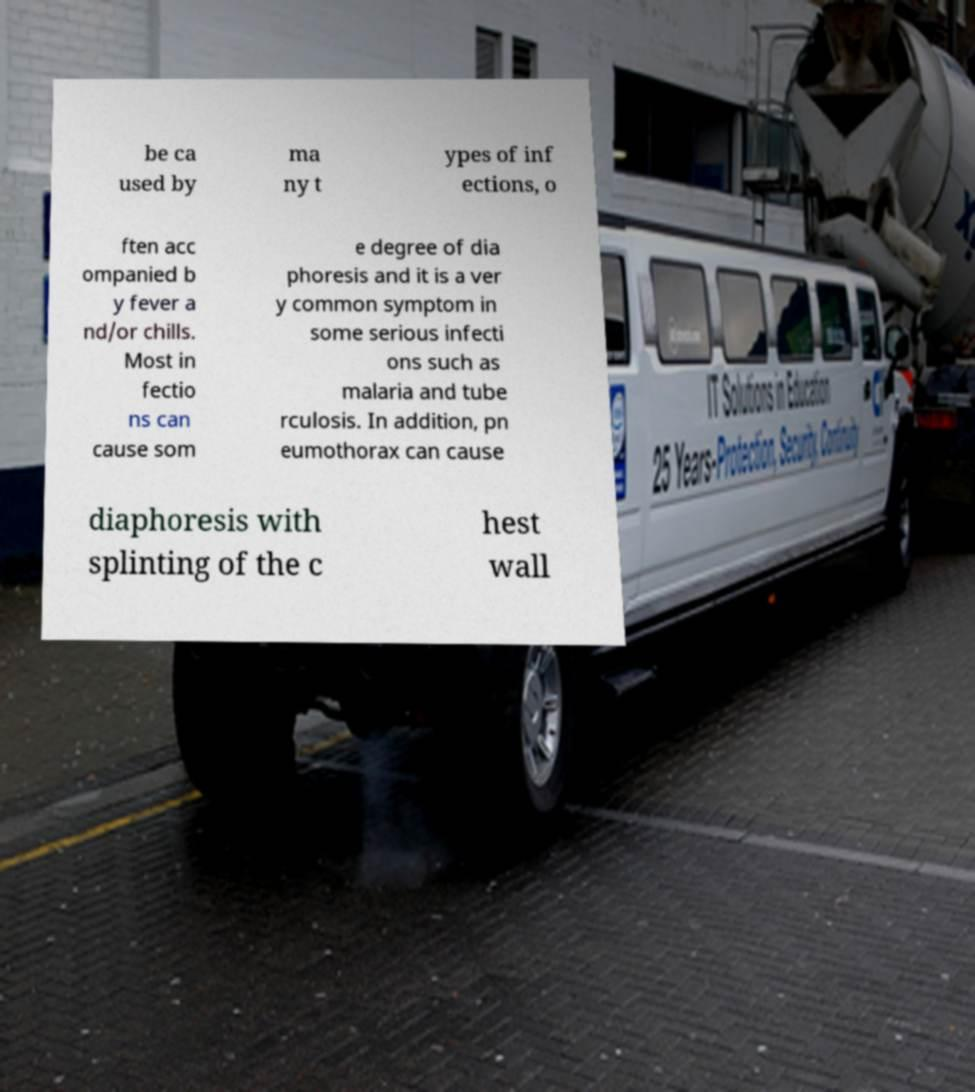Could you assist in decoding the text presented in this image and type it out clearly? be ca used by ma ny t ypes of inf ections, o ften acc ompanied b y fever a nd/or chills. Most in fectio ns can cause som e degree of dia phoresis and it is a ver y common symptom in some serious infecti ons such as malaria and tube rculosis. In addition, pn eumothorax can cause diaphoresis with splinting of the c hest wall 